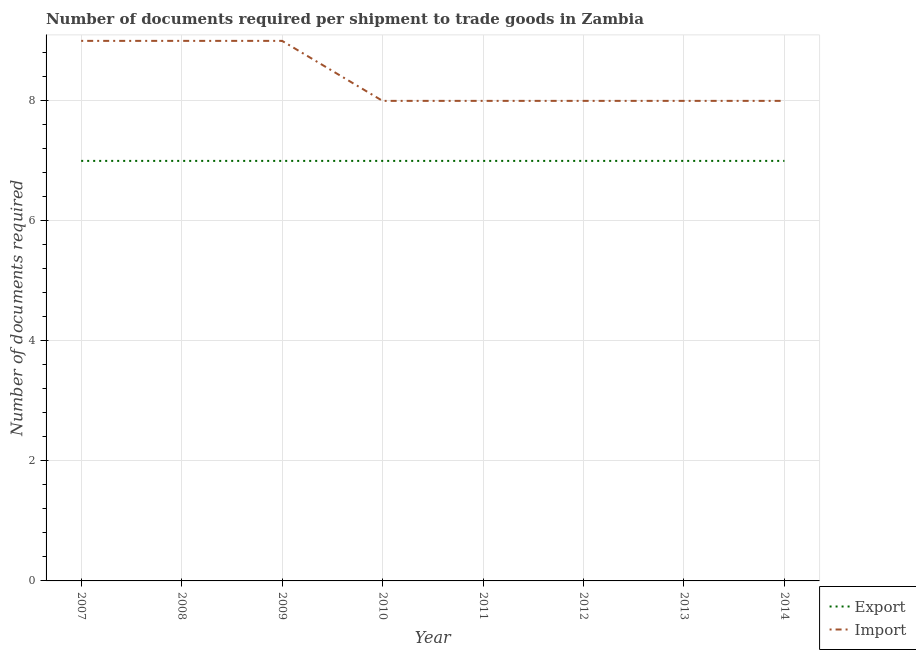How many different coloured lines are there?
Keep it short and to the point. 2. Does the line corresponding to number of documents required to export goods intersect with the line corresponding to number of documents required to import goods?
Ensure brevity in your answer.  No. What is the number of documents required to import goods in 2014?
Offer a terse response. 8. Across all years, what is the maximum number of documents required to import goods?
Your answer should be compact. 9. Across all years, what is the minimum number of documents required to import goods?
Your response must be concise. 8. In which year was the number of documents required to import goods minimum?
Your answer should be very brief. 2010. What is the total number of documents required to export goods in the graph?
Offer a terse response. 56. What is the difference between the number of documents required to export goods in 2013 and the number of documents required to import goods in 2007?
Give a very brief answer. -2. What is the average number of documents required to export goods per year?
Provide a succinct answer. 7. In the year 2008, what is the difference between the number of documents required to import goods and number of documents required to export goods?
Provide a short and direct response. 2. What is the ratio of the number of documents required to export goods in 2009 to that in 2011?
Your response must be concise. 1. Is the number of documents required to export goods in 2008 less than that in 2011?
Make the answer very short. No. What is the difference between the highest and the lowest number of documents required to export goods?
Provide a succinct answer. 0. In how many years, is the number of documents required to export goods greater than the average number of documents required to export goods taken over all years?
Offer a terse response. 0. Does the number of documents required to export goods monotonically increase over the years?
Give a very brief answer. No. Is the number of documents required to import goods strictly less than the number of documents required to export goods over the years?
Keep it short and to the point. No. How many lines are there?
Make the answer very short. 2. How many years are there in the graph?
Offer a terse response. 8. What is the difference between two consecutive major ticks on the Y-axis?
Provide a short and direct response. 2. Are the values on the major ticks of Y-axis written in scientific E-notation?
Provide a short and direct response. No. Does the graph contain any zero values?
Your answer should be compact. No. Does the graph contain grids?
Offer a terse response. Yes. How many legend labels are there?
Provide a succinct answer. 2. What is the title of the graph?
Give a very brief answer. Number of documents required per shipment to trade goods in Zambia. What is the label or title of the Y-axis?
Ensure brevity in your answer.  Number of documents required. What is the Number of documents required of Import in 2007?
Offer a very short reply. 9. What is the Number of documents required in Import in 2008?
Your answer should be compact. 9. What is the Number of documents required of Export in 2009?
Provide a succinct answer. 7. What is the Number of documents required of Export in 2011?
Provide a succinct answer. 7. What is the Number of documents required of Export in 2012?
Make the answer very short. 7. What is the Number of documents required in Export in 2013?
Keep it short and to the point. 7. What is the Number of documents required of Import in 2013?
Your answer should be compact. 8. What is the total Number of documents required of Import in the graph?
Your response must be concise. 67. What is the difference between the Number of documents required in Import in 2007 and that in 2008?
Make the answer very short. 0. What is the difference between the Number of documents required of Export in 2007 and that in 2009?
Your answer should be very brief. 0. What is the difference between the Number of documents required in Import in 2007 and that in 2009?
Offer a terse response. 0. What is the difference between the Number of documents required of Export in 2007 and that in 2010?
Your response must be concise. 0. What is the difference between the Number of documents required of Import in 2007 and that in 2011?
Ensure brevity in your answer.  1. What is the difference between the Number of documents required of Export in 2007 and that in 2012?
Your response must be concise. 0. What is the difference between the Number of documents required of Export in 2007 and that in 2013?
Offer a very short reply. 0. What is the difference between the Number of documents required of Export in 2008 and that in 2009?
Offer a very short reply. 0. What is the difference between the Number of documents required of Import in 2008 and that in 2009?
Your response must be concise. 0. What is the difference between the Number of documents required of Export in 2008 and that in 2010?
Make the answer very short. 0. What is the difference between the Number of documents required of Import in 2008 and that in 2010?
Make the answer very short. 1. What is the difference between the Number of documents required in Export in 2008 and that in 2011?
Offer a terse response. 0. What is the difference between the Number of documents required of Export in 2008 and that in 2012?
Your response must be concise. 0. What is the difference between the Number of documents required in Import in 2008 and that in 2012?
Make the answer very short. 1. What is the difference between the Number of documents required in Import in 2008 and that in 2014?
Make the answer very short. 1. What is the difference between the Number of documents required in Export in 2009 and that in 2010?
Provide a succinct answer. 0. What is the difference between the Number of documents required of Export in 2009 and that in 2011?
Your answer should be compact. 0. What is the difference between the Number of documents required in Export in 2009 and that in 2012?
Your answer should be very brief. 0. What is the difference between the Number of documents required in Import in 2009 and that in 2012?
Offer a terse response. 1. What is the difference between the Number of documents required in Export in 2009 and that in 2014?
Your answer should be compact. 0. What is the difference between the Number of documents required in Import in 2009 and that in 2014?
Your response must be concise. 1. What is the difference between the Number of documents required in Export in 2010 and that in 2011?
Make the answer very short. 0. What is the difference between the Number of documents required in Export in 2010 and that in 2012?
Your answer should be compact. 0. What is the difference between the Number of documents required in Export in 2010 and that in 2013?
Give a very brief answer. 0. What is the difference between the Number of documents required of Export in 2011 and that in 2014?
Offer a terse response. 0. What is the difference between the Number of documents required in Import in 2013 and that in 2014?
Provide a short and direct response. 0. What is the difference between the Number of documents required in Export in 2007 and the Number of documents required in Import in 2008?
Your response must be concise. -2. What is the difference between the Number of documents required of Export in 2007 and the Number of documents required of Import in 2009?
Provide a succinct answer. -2. What is the difference between the Number of documents required in Export in 2007 and the Number of documents required in Import in 2012?
Offer a terse response. -1. What is the difference between the Number of documents required of Export in 2008 and the Number of documents required of Import in 2009?
Provide a succinct answer. -2. What is the difference between the Number of documents required of Export in 2009 and the Number of documents required of Import in 2012?
Your response must be concise. -1. What is the difference between the Number of documents required of Export in 2009 and the Number of documents required of Import in 2013?
Give a very brief answer. -1. What is the difference between the Number of documents required of Export in 2009 and the Number of documents required of Import in 2014?
Provide a succinct answer. -1. What is the difference between the Number of documents required of Export in 2010 and the Number of documents required of Import in 2012?
Provide a short and direct response. -1. What is the difference between the Number of documents required of Export in 2010 and the Number of documents required of Import in 2014?
Give a very brief answer. -1. What is the difference between the Number of documents required in Export in 2011 and the Number of documents required in Import in 2012?
Your answer should be very brief. -1. What is the difference between the Number of documents required of Export in 2011 and the Number of documents required of Import in 2013?
Keep it short and to the point. -1. What is the difference between the Number of documents required in Export in 2011 and the Number of documents required in Import in 2014?
Give a very brief answer. -1. What is the difference between the Number of documents required in Export in 2012 and the Number of documents required in Import in 2013?
Your answer should be very brief. -1. What is the difference between the Number of documents required in Export in 2012 and the Number of documents required in Import in 2014?
Keep it short and to the point. -1. What is the average Number of documents required in Export per year?
Offer a very short reply. 7. What is the average Number of documents required of Import per year?
Your answer should be compact. 8.38. In the year 2008, what is the difference between the Number of documents required of Export and Number of documents required of Import?
Keep it short and to the point. -2. In the year 2009, what is the difference between the Number of documents required in Export and Number of documents required in Import?
Give a very brief answer. -2. In the year 2010, what is the difference between the Number of documents required of Export and Number of documents required of Import?
Your answer should be very brief. -1. In the year 2011, what is the difference between the Number of documents required of Export and Number of documents required of Import?
Ensure brevity in your answer.  -1. In the year 2012, what is the difference between the Number of documents required of Export and Number of documents required of Import?
Ensure brevity in your answer.  -1. In the year 2013, what is the difference between the Number of documents required in Export and Number of documents required in Import?
Your answer should be compact. -1. In the year 2014, what is the difference between the Number of documents required in Export and Number of documents required in Import?
Your response must be concise. -1. What is the ratio of the Number of documents required of Import in 2007 to that in 2008?
Offer a terse response. 1. What is the ratio of the Number of documents required of Export in 2007 to that in 2009?
Your answer should be very brief. 1. What is the ratio of the Number of documents required of Import in 2007 to that in 2010?
Keep it short and to the point. 1.12. What is the ratio of the Number of documents required in Import in 2007 to that in 2011?
Your answer should be very brief. 1.12. What is the ratio of the Number of documents required in Export in 2007 to that in 2012?
Offer a very short reply. 1. What is the ratio of the Number of documents required of Import in 2007 to that in 2012?
Give a very brief answer. 1.12. What is the ratio of the Number of documents required of Export in 2008 to that in 2010?
Your answer should be compact. 1. What is the ratio of the Number of documents required in Import in 2008 to that in 2010?
Your answer should be very brief. 1.12. What is the ratio of the Number of documents required in Import in 2008 to that in 2011?
Ensure brevity in your answer.  1.12. What is the ratio of the Number of documents required in Export in 2008 to that in 2013?
Your answer should be very brief. 1. What is the ratio of the Number of documents required of Import in 2008 to that in 2014?
Your answer should be compact. 1.12. What is the ratio of the Number of documents required of Export in 2009 to that in 2010?
Provide a short and direct response. 1. What is the ratio of the Number of documents required of Import in 2009 to that in 2010?
Your answer should be very brief. 1.12. What is the ratio of the Number of documents required in Import in 2009 to that in 2011?
Ensure brevity in your answer.  1.12. What is the ratio of the Number of documents required in Export in 2009 to that in 2014?
Your response must be concise. 1. What is the ratio of the Number of documents required of Import in 2009 to that in 2014?
Ensure brevity in your answer.  1.12. What is the ratio of the Number of documents required in Import in 2010 to that in 2011?
Give a very brief answer. 1. What is the ratio of the Number of documents required of Import in 2010 to that in 2012?
Offer a very short reply. 1. What is the ratio of the Number of documents required of Export in 2010 to that in 2013?
Provide a succinct answer. 1. What is the ratio of the Number of documents required in Import in 2010 to that in 2013?
Offer a terse response. 1. What is the ratio of the Number of documents required in Export in 2010 to that in 2014?
Offer a very short reply. 1. What is the ratio of the Number of documents required of Import in 2011 to that in 2012?
Offer a very short reply. 1. What is the ratio of the Number of documents required in Export in 2011 to that in 2013?
Give a very brief answer. 1. What is the ratio of the Number of documents required in Import in 2011 to that in 2014?
Your response must be concise. 1. What is the ratio of the Number of documents required in Export in 2012 to that in 2014?
Offer a very short reply. 1. What is the ratio of the Number of documents required in Export in 2013 to that in 2014?
Offer a terse response. 1. What is the ratio of the Number of documents required in Import in 2013 to that in 2014?
Provide a short and direct response. 1. What is the difference between the highest and the lowest Number of documents required of Export?
Ensure brevity in your answer.  0. What is the difference between the highest and the lowest Number of documents required in Import?
Offer a very short reply. 1. 